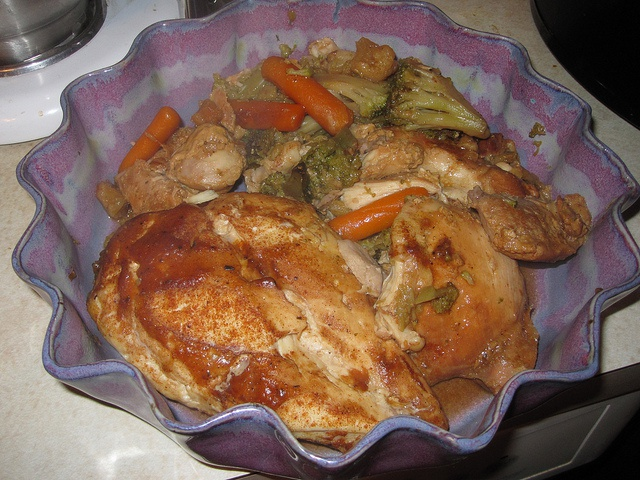Describe the objects in this image and their specific colors. I can see bowl in gray, brown, and maroon tones, sandwich in gray, brown, and maroon tones, broccoli in gray, olive, and maroon tones, broccoli in gray, olive, and maroon tones, and carrot in gray, brown, and maroon tones in this image. 